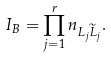Convert formula to latex. <formula><loc_0><loc_0><loc_500><loc_500>I _ { B } = \prod _ { j = 1 } ^ { r } { n } _ { L _ { j } \widetilde { L } _ { j } } .</formula> 